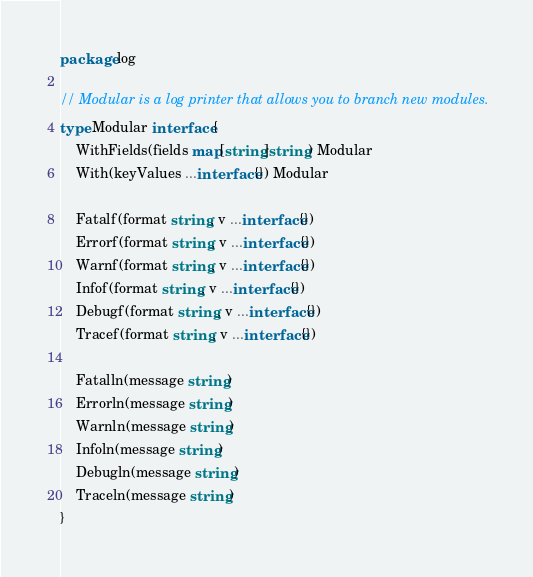<code> <loc_0><loc_0><loc_500><loc_500><_Go_>package log

// Modular is a log printer that allows you to branch new modules.
type Modular interface {
	WithFields(fields map[string]string) Modular
	With(keyValues ...interface{}) Modular

	Fatalf(format string, v ...interface{})
	Errorf(format string, v ...interface{})
	Warnf(format string, v ...interface{})
	Infof(format string, v ...interface{})
	Debugf(format string, v ...interface{})
	Tracef(format string, v ...interface{})

	Fatalln(message string)
	Errorln(message string)
	Warnln(message string)
	Infoln(message string)
	Debugln(message string)
	Traceln(message string)
}
</code> 